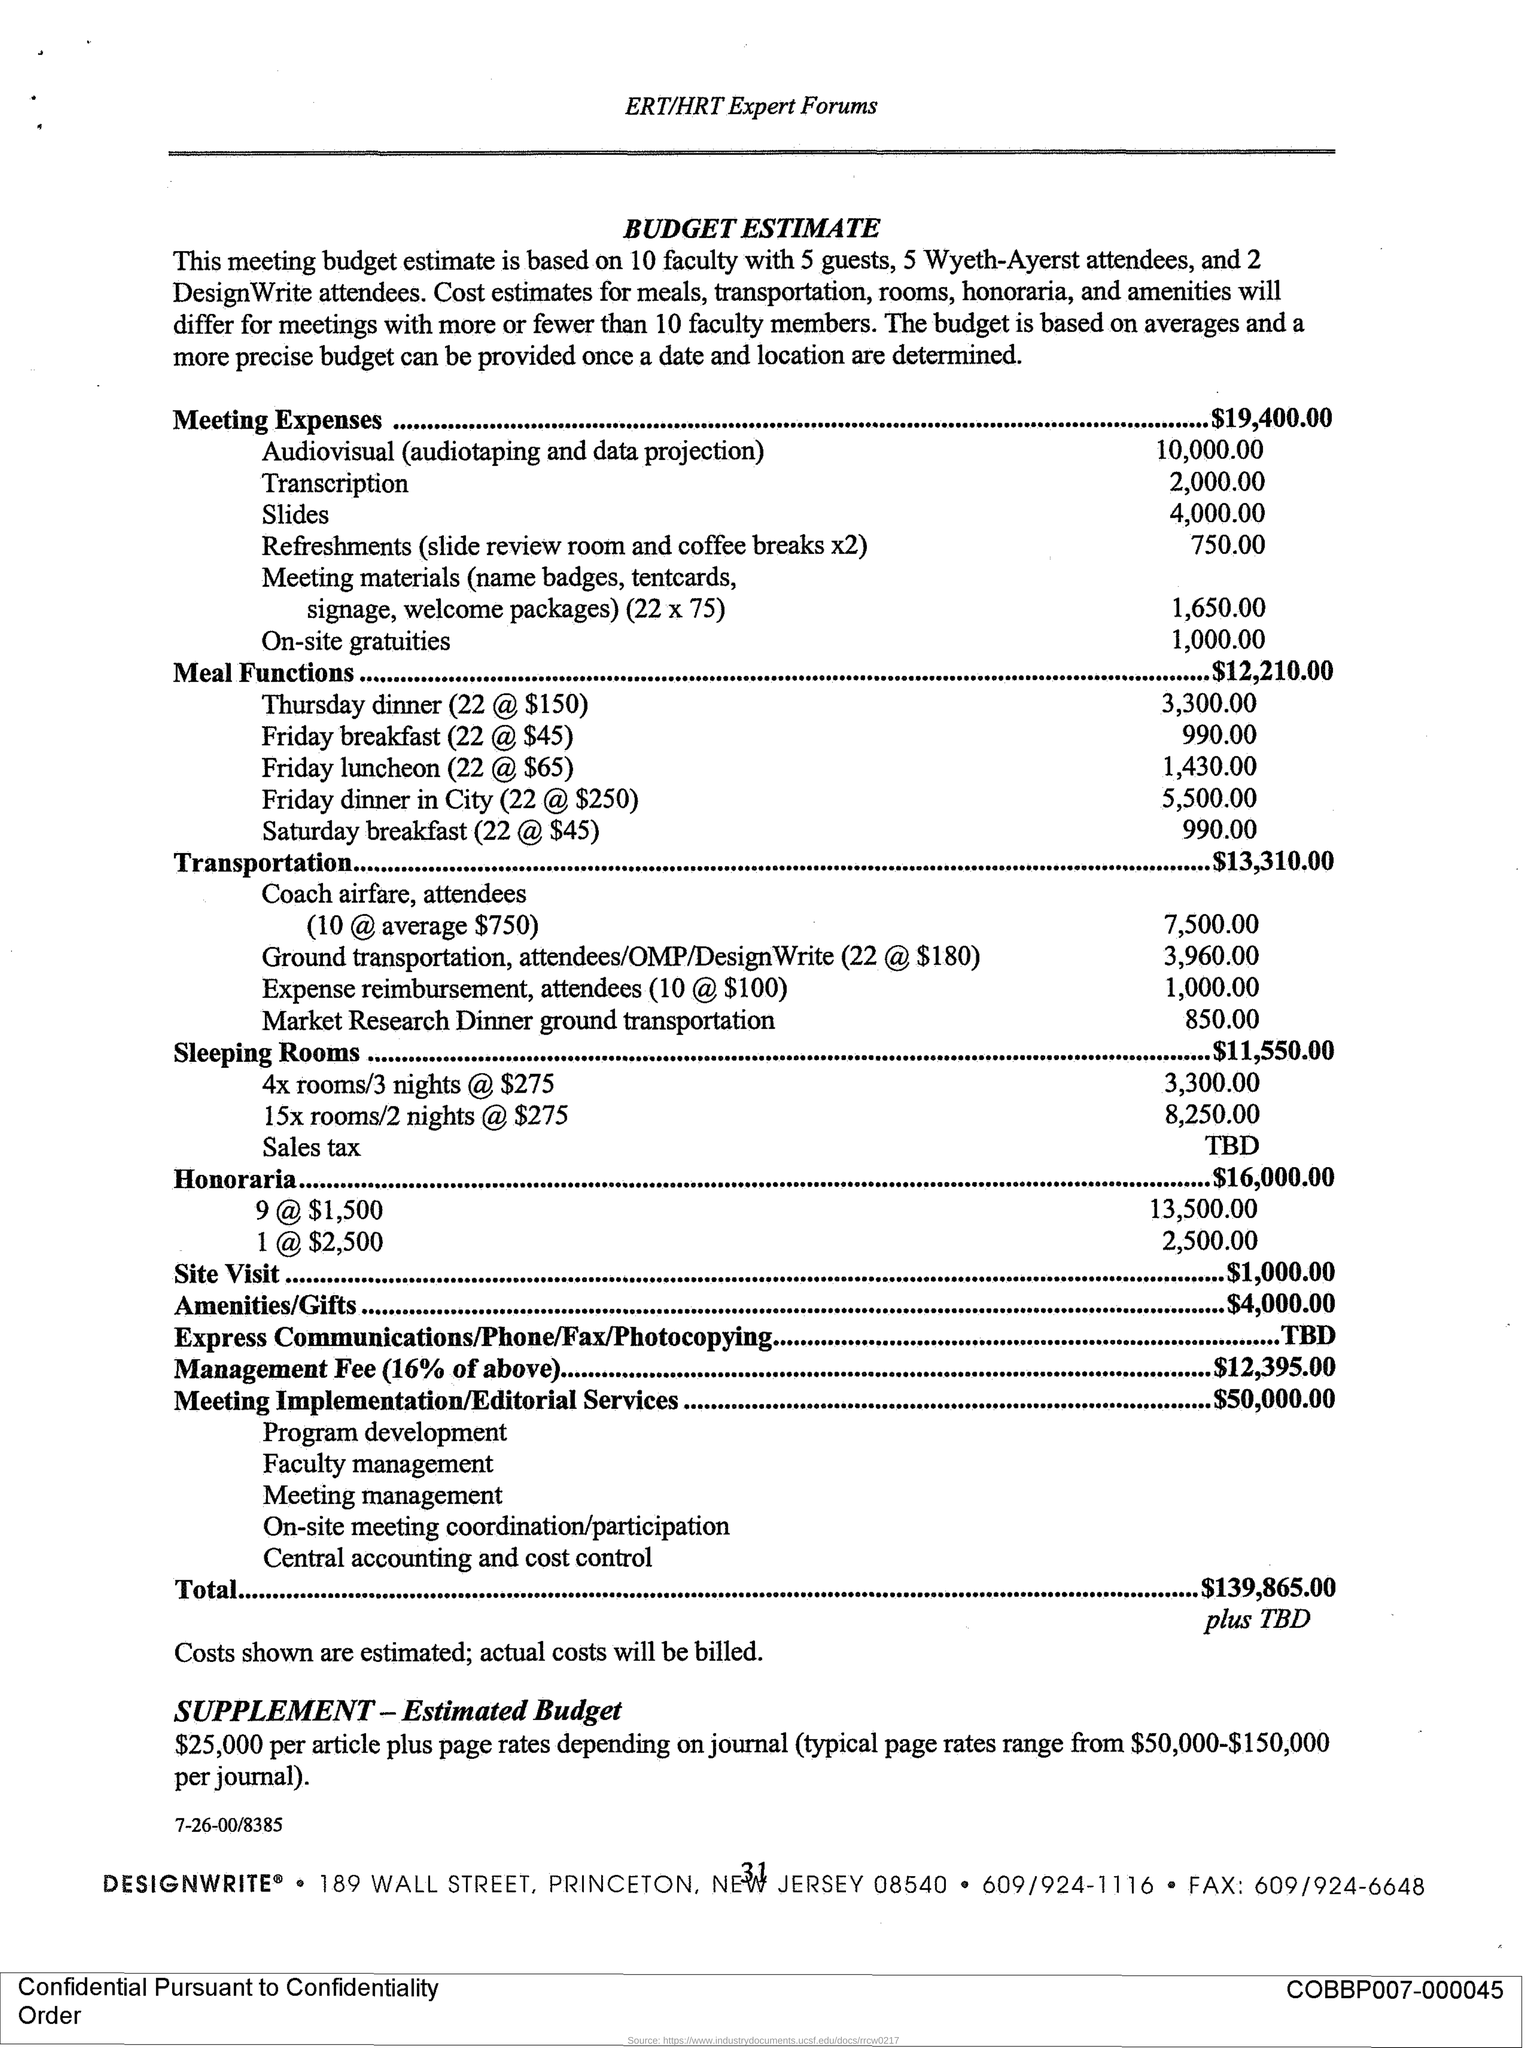Highlight a few significant elements in this photo. The total expenses for the meeting are $19,400.00. The typical page rates for scientific journals are provided in the "Supplement estimated budget" and range from $50,000 to $150,000 per journal. 